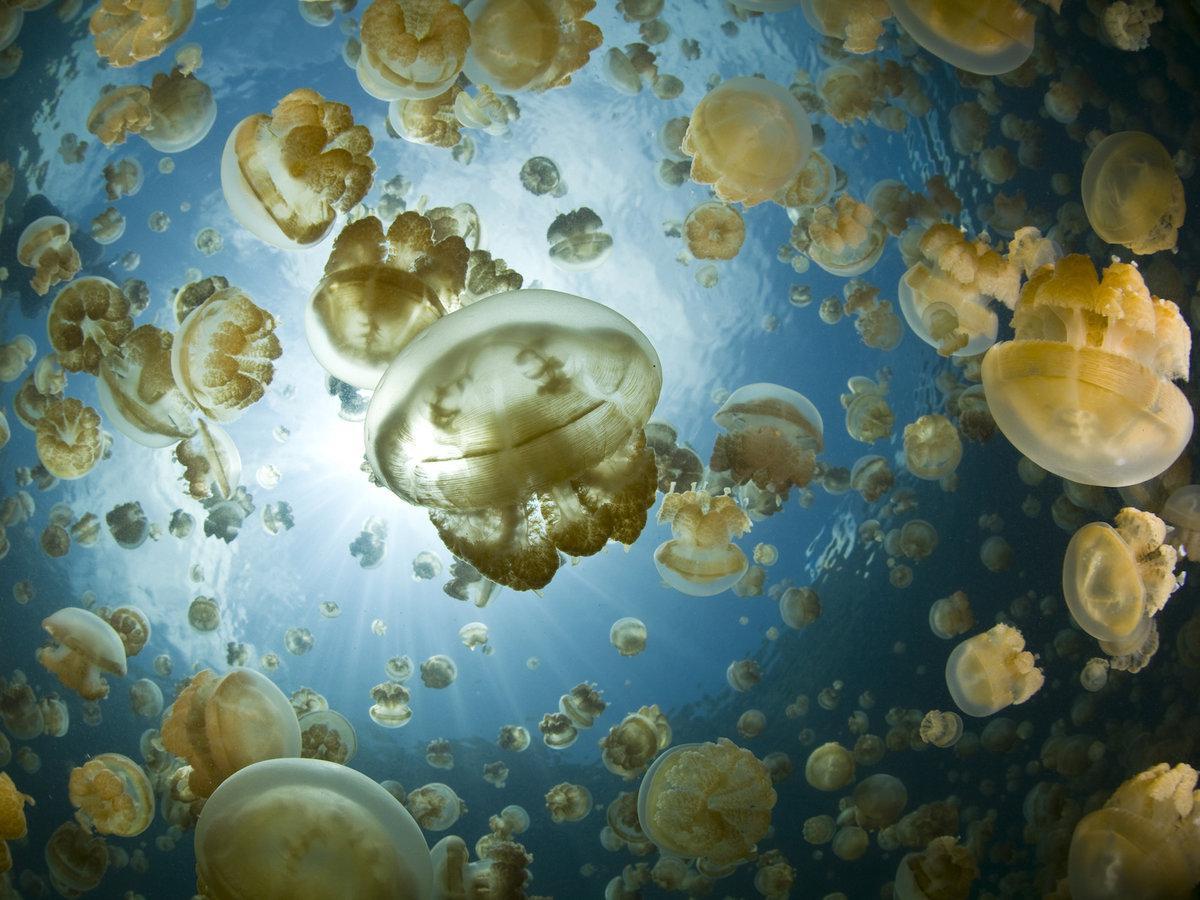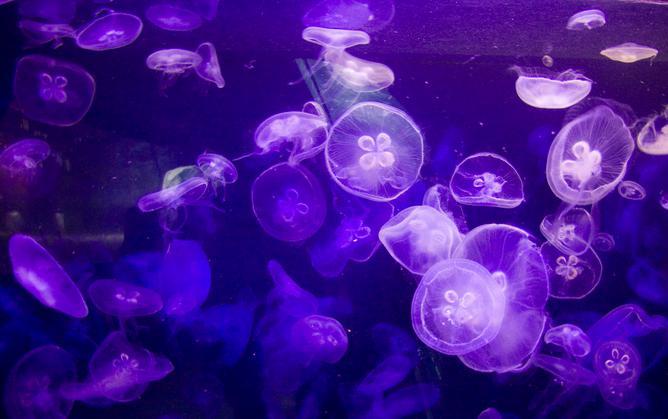The first image is the image on the left, the second image is the image on the right. For the images shown, is this caption "An image shows at least six vivid orange jellyfish trailing tendrils." true? Answer yes or no. No. 